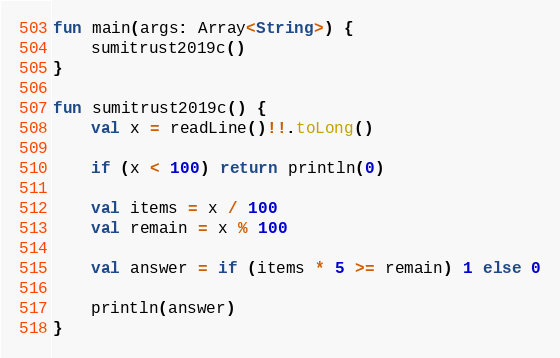Convert code to text. <code><loc_0><loc_0><loc_500><loc_500><_Kotlin_>fun main(args: Array<String>) {
    sumitrust2019c()
}

fun sumitrust2019c() {
    val x = readLine()!!.toLong()

    if (x < 100) return println(0)

    val items = x / 100
    val remain = x % 100

    val answer = if (items * 5 >= remain) 1 else 0

    println(answer)
}
</code> 